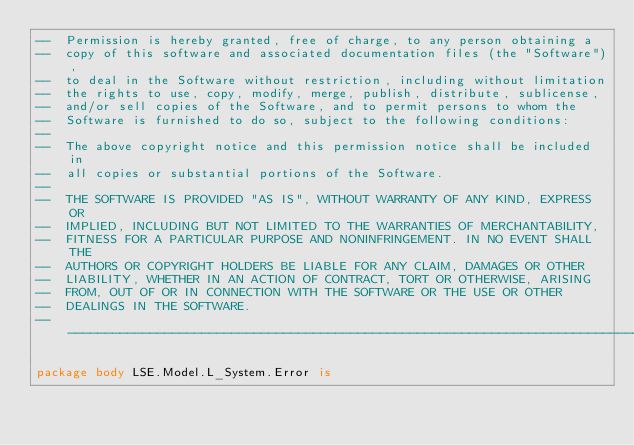Convert code to text. <code><loc_0><loc_0><loc_500><loc_500><_Ada_>--  Permission is hereby granted, free of charge, to any person obtaining a
--  copy of this software and associated documentation files (the "Software"),
--  to deal in the Software without restriction, including without limitation
--  the rights to use, copy, modify, merge, publish, distribute, sublicense,
--  and/or sell copies of the Software, and to permit persons to whom the
--  Software is furnished to do so, subject to the following conditions:
--
--  The above copyright notice and this permission notice shall be included in
--  all copies or substantial portions of the Software.
--
--  THE SOFTWARE IS PROVIDED "AS IS", WITHOUT WARRANTY OF ANY KIND, EXPRESS OR
--  IMPLIED, INCLUDING BUT NOT LIMITED TO THE WARRANTIES OF MERCHANTABILITY,
--  FITNESS FOR A PARTICULAR PURPOSE AND NONINFRINGEMENT. IN NO EVENT SHALL THE
--  AUTHORS OR COPYRIGHT HOLDERS BE LIABLE FOR ANY CLAIM, DAMAGES OR OTHER
--  LIABILITY, WHETHER IN AN ACTION OF CONTRACT, TORT OR OTHERWISE, ARISING
--  FROM, OUT OF OR IN CONNECTION WITH THE SOFTWARE OR THE USE OR OTHER
--  DEALINGS IN THE SOFTWARE.
-------------------------------------------------------------------------------

package body LSE.Model.L_System.Error is
</code> 